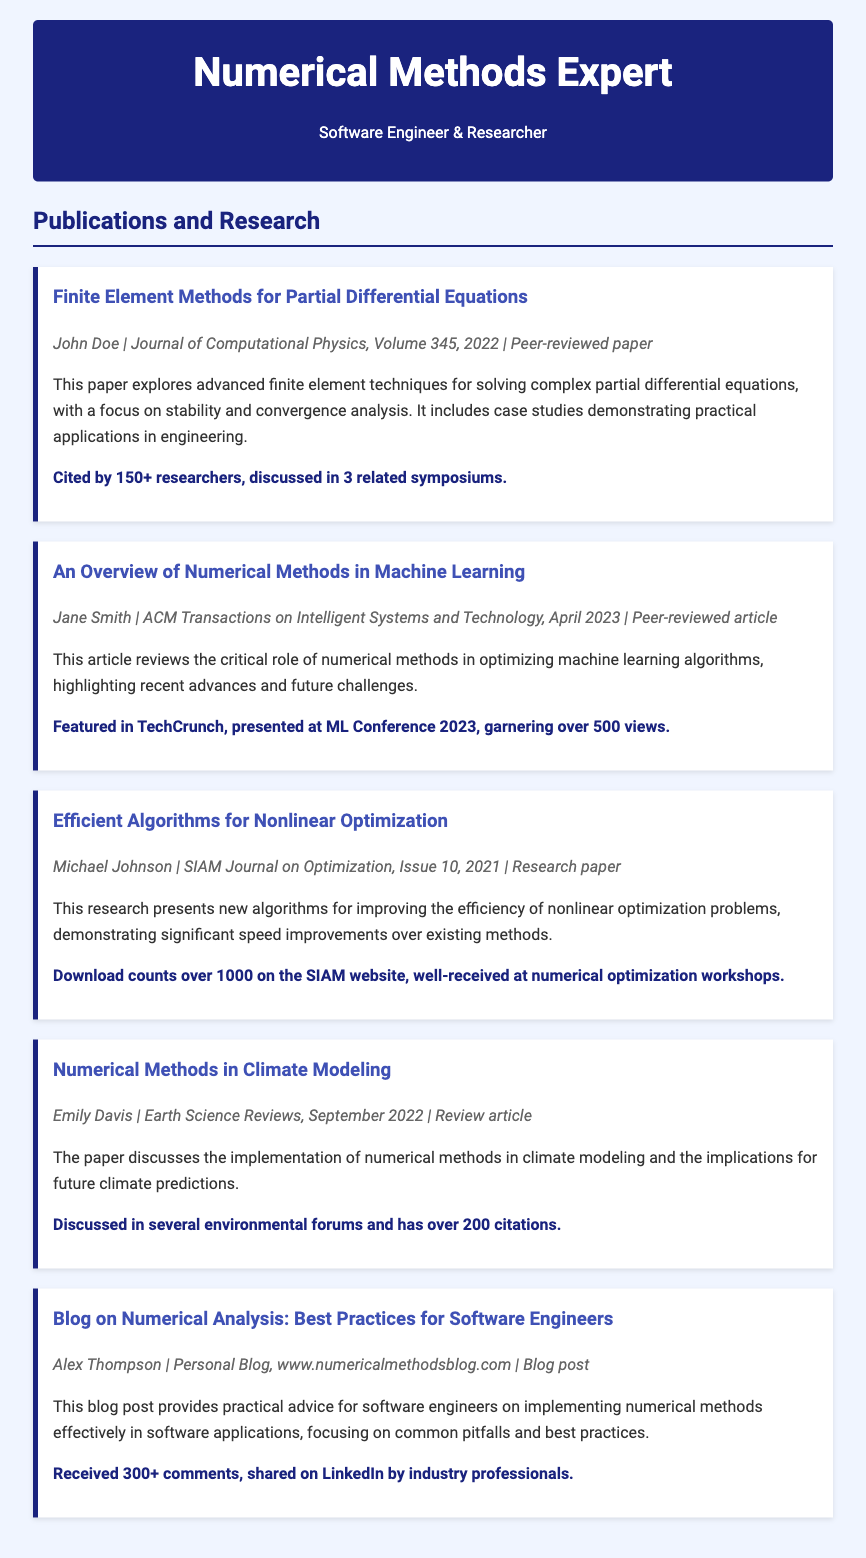what is the title of the first publication? The title of the first publication is explicitly stated in the document, which is "Finite Element Methods for Partial Differential Equations."
Answer: Finite Element Methods for Partial Differential Equations who authored the article titled "An Overview of Numerical Methods in Machine Learning"? The document lists Jane Smith as the author of this article.
Answer: Jane Smith how many citations does "Numerical Methods in Climate Modeling" have? The number of citations for this publication is mentioned in the engagement section, which states it has over 200 citations.
Answer: over 200 which journal published the research paper on "Efficient Algorithms for Nonlinear Optimization"? The journal name is provided in the publication details for this paper, which is the SIAM Journal on Optimization.
Answer: SIAM Journal on Optimization what was the main focus of the blog post by Alex Thompson? The blog post's summary indicates that it provides practical advice for software engineers on implementing numerical methods effectively.
Answer: practical advice for software engineers how many views did the article "An Overview of Numerical Methods in Machine Learning" garner? The engagement section specifies that the article received over 500 views.
Answer: over 500 what type of article is "Finite Element Methods for Partial Differential Equations"? The document specifically states that this is a peer-reviewed paper.
Answer: peer-reviewed paper who presented the research paper on efficient algorithms at workshops? The engagement section mentions that this paper was well-received at numerical optimization workshops, but does not specify a personal name.
Answer: Not specified 